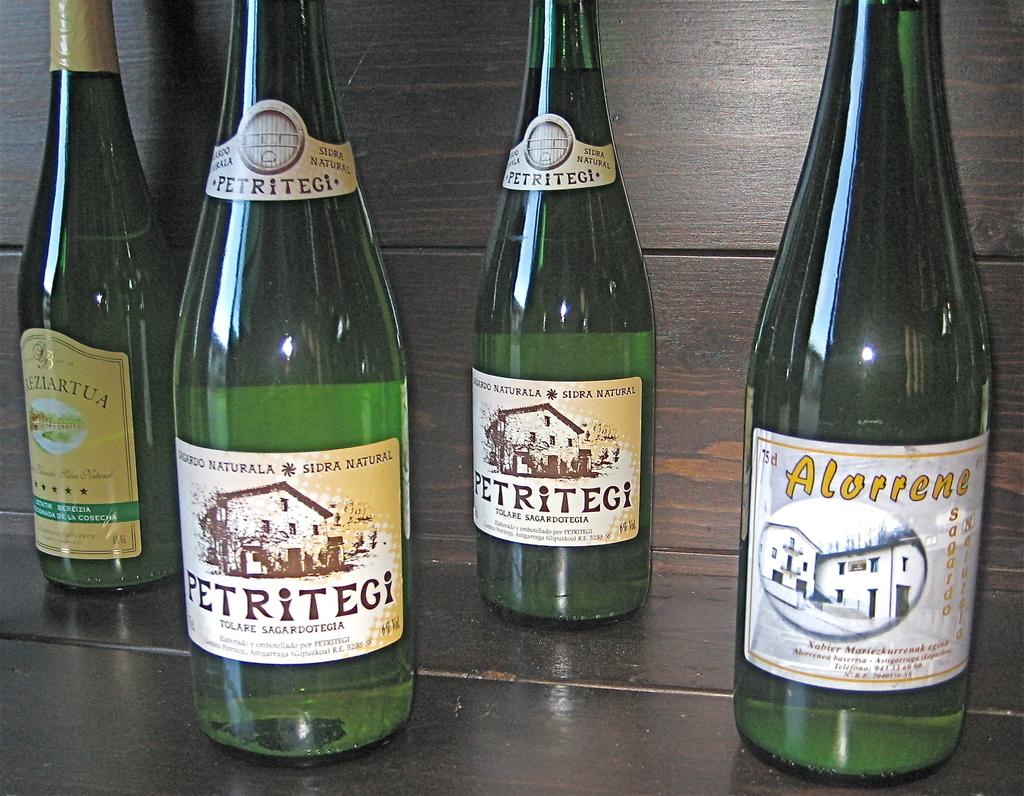What is the name of the far right drink?
Provide a succinct answer. Alorrene. What is the drink that has two bottles?
Offer a very short reply. Petritegi. 